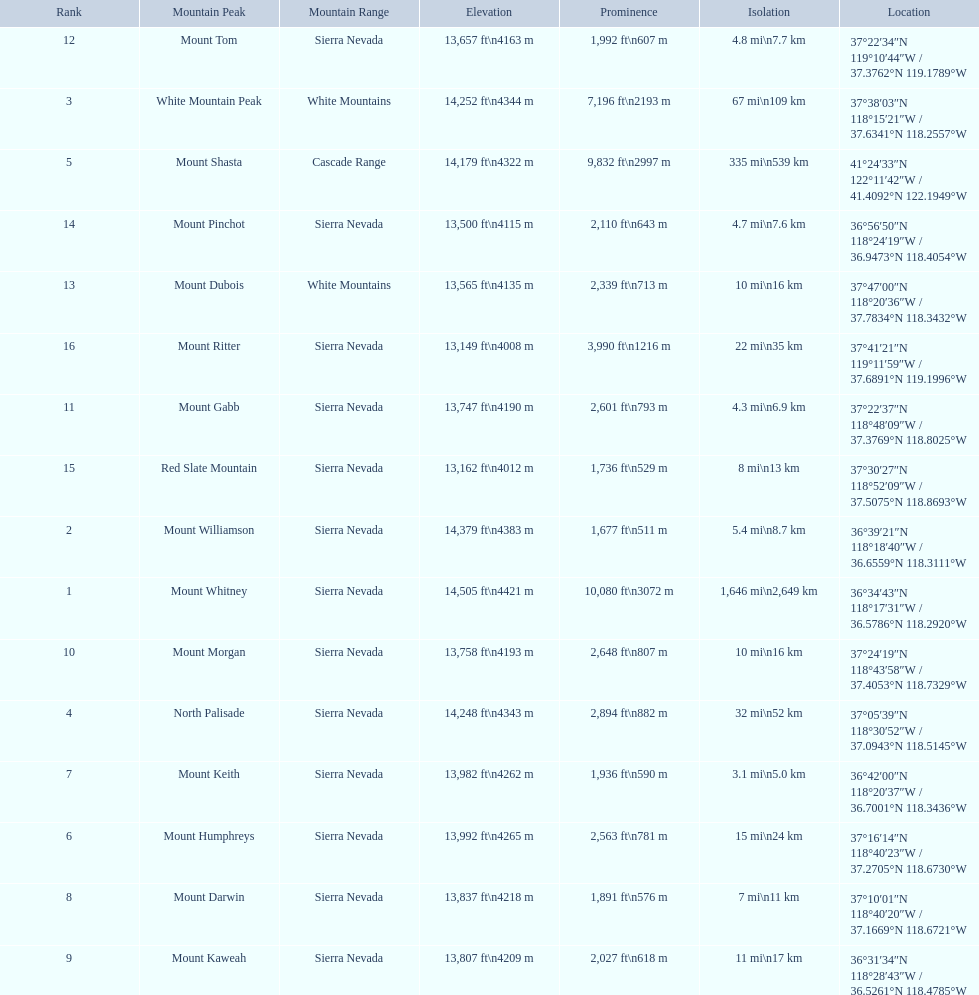Which mountain peaks are lower than 14,000 ft? Mount Humphreys, Mount Keith, Mount Darwin, Mount Kaweah, Mount Morgan, Mount Gabb, Mount Tom, Mount Dubois, Mount Pinchot, Red Slate Mountain, Mount Ritter. Are any of them below 13,500? if so, which ones? Red Slate Mountain, Mount Ritter. What's the lowest peak? 13,149 ft\n4008 m. Which one is that? Mount Ritter. 